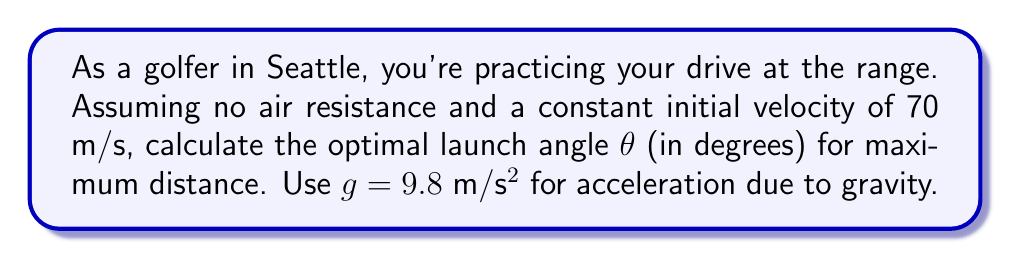Give your solution to this math problem. To find the optimal launch angle for maximum distance, we need to consider the projectile motion of the golf ball. The range equation for a projectile launched from ground level is:

$$R = \frac{v_0^2}{g} \sin(2\theta)$$

Where:
- $R$ is the range (distance)
- $v_0$ is the initial velocity
- $g$ is the acceleration due to gravity
- $\theta$ is the launch angle

To maximize the range, we need to maximize $\sin(2\theta)$. The sine function reaches its maximum value of 1 when its argument is 90°. Therefore:

$$2\theta = 90°$$
$$\theta = 45°$$

This result is independent of the initial velocity and the acceleration due to gravity, making it universally applicable for projectile motion in a vacuum.

In reality, factors like air resistance and the golf ball's spin would affect the optimal launch angle, typically reducing it to around 10-15° for a golf drive. However, for the idealized case presented in this problem, 45° remains the optimal angle.
Answer: The optimal launch angle for maximum distance is 45°. 